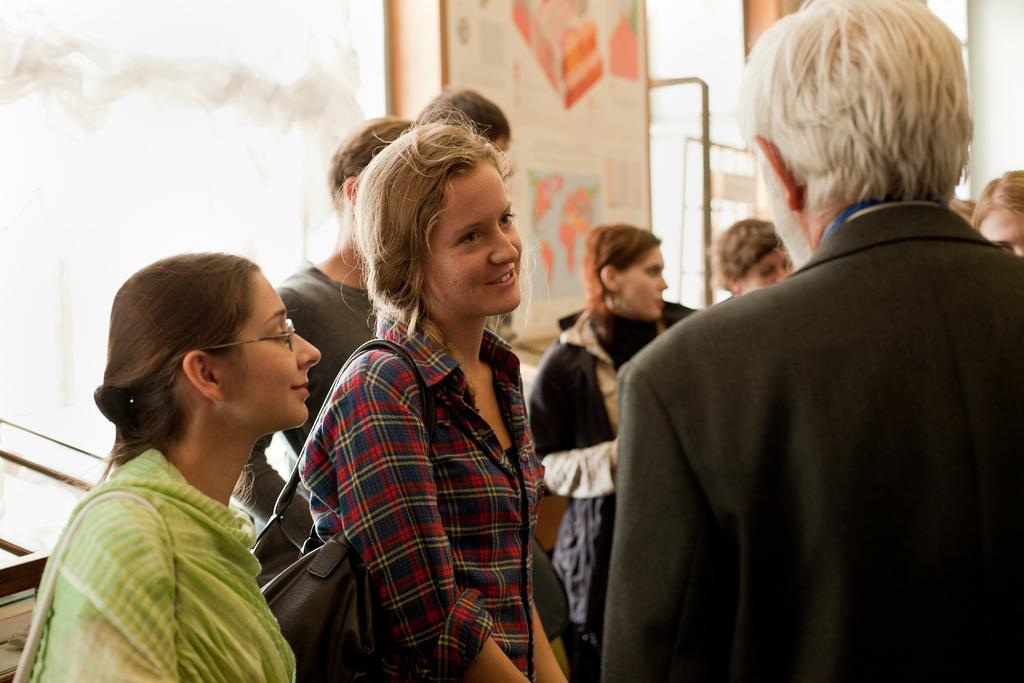What is present in the image? There are people standing in the image. Can you describe the surface on which the people are standing? The people are standing on the floor. What type of ship can be seen sailing in the background of the image? There is no ship present in the image; it only features people standing on the floor. How many roses are visible in the image? There are no roses present in the image. 